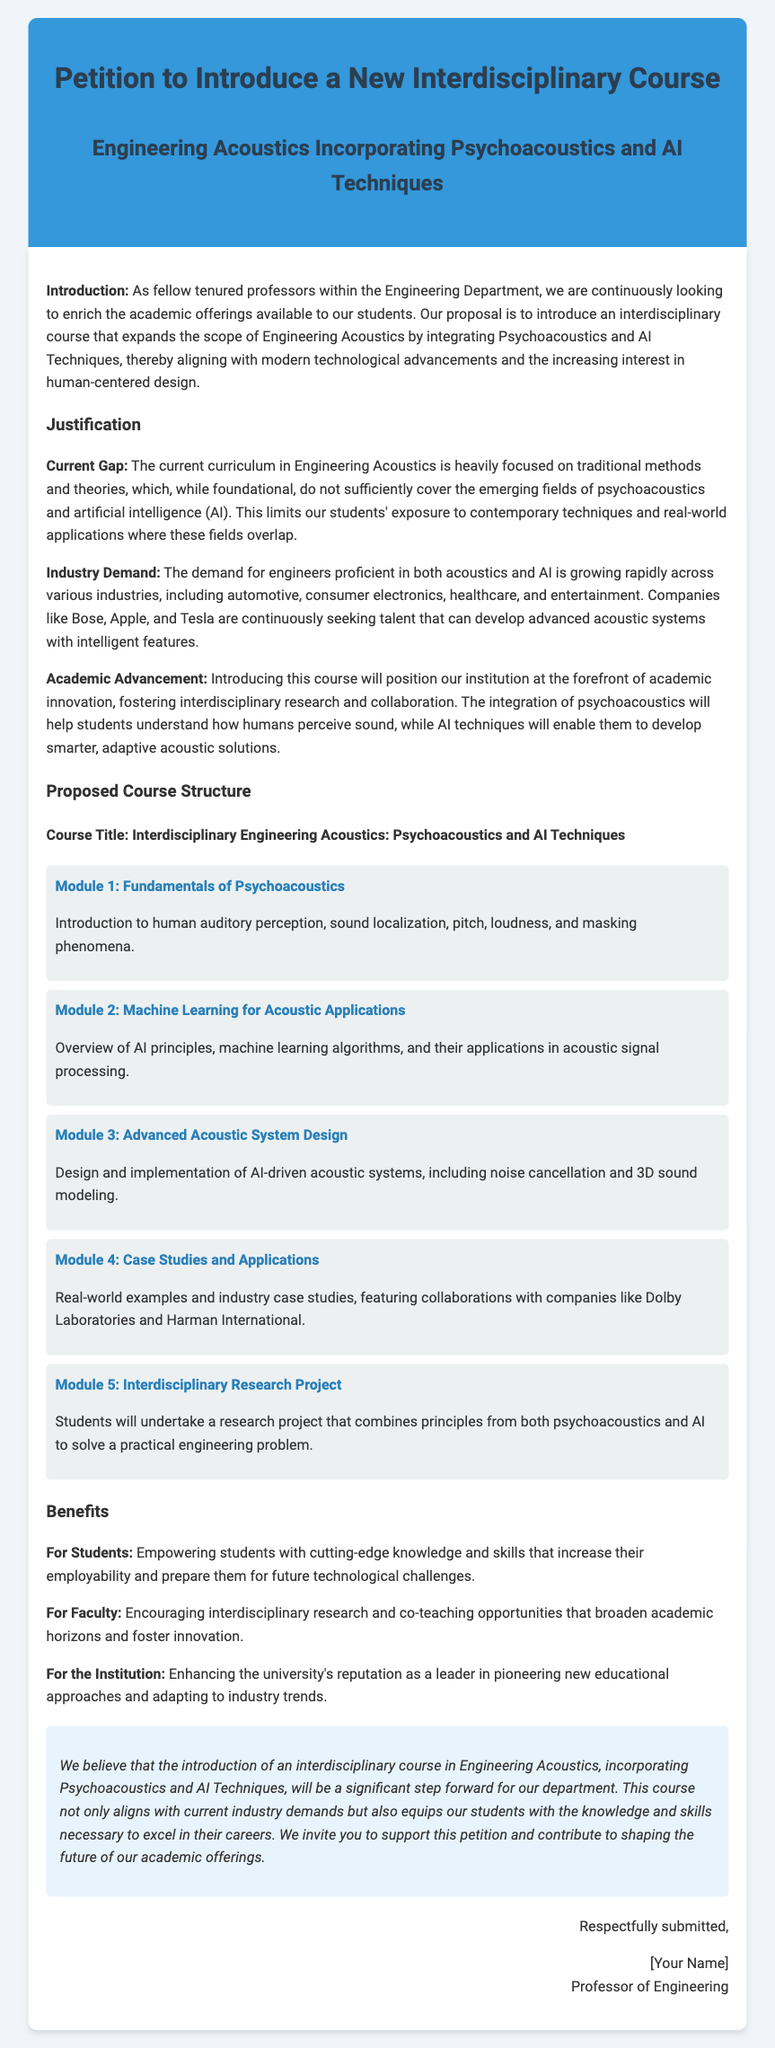What is the proposed course title? The proposed course title is explicitly mentioned in the document under the proposed course structure.
Answer: Interdisciplinary Engineering Acoustics: Psychoacoustics and AI Techniques What are the first two modules of the course? The first two modules are listed in the course structure section, detailing the content of each module.
Answer: Fundamentals of Psychoacoustics, Machine Learning for Acoustic Applications Who are some of the companies mentioned in the industry demand section? The document specifically lists examples of companies seeking talent in the field of acoustics and AI.
Answer: Bose, Apple, Tesla How many modules are in the proposed course structure? The document specifies the total number of modules included in the proposed course structure.
Answer: Five What is one of the benefits for students mentioned in the document? The document outlines various benefits for students, and one of the benefits explicitly mentioned.
Answer: Empowering students with cutting-edge knowledge What is the primary goal of the proposed course? The primary goal of the proposed course is described in the justification section and serves as a foundation for the petition.
Answer: An interdisciplinary course in Engineering Acoustics What type of project will students undertake in the course? The document discusses the type of project included in the course, which combines different principles.
Answer: Interdisciplinary Research Project Which faculty or department is leading this petition? The document indicates the academic group proposing this new course through the introductory section.
Answer: Engineering Department What is a key industry that demands skills in both acoustics and AI? A specific industry is highlighted in the document as having an increasing demand for relevant talent in this dual domain.
Answer: Automotive 